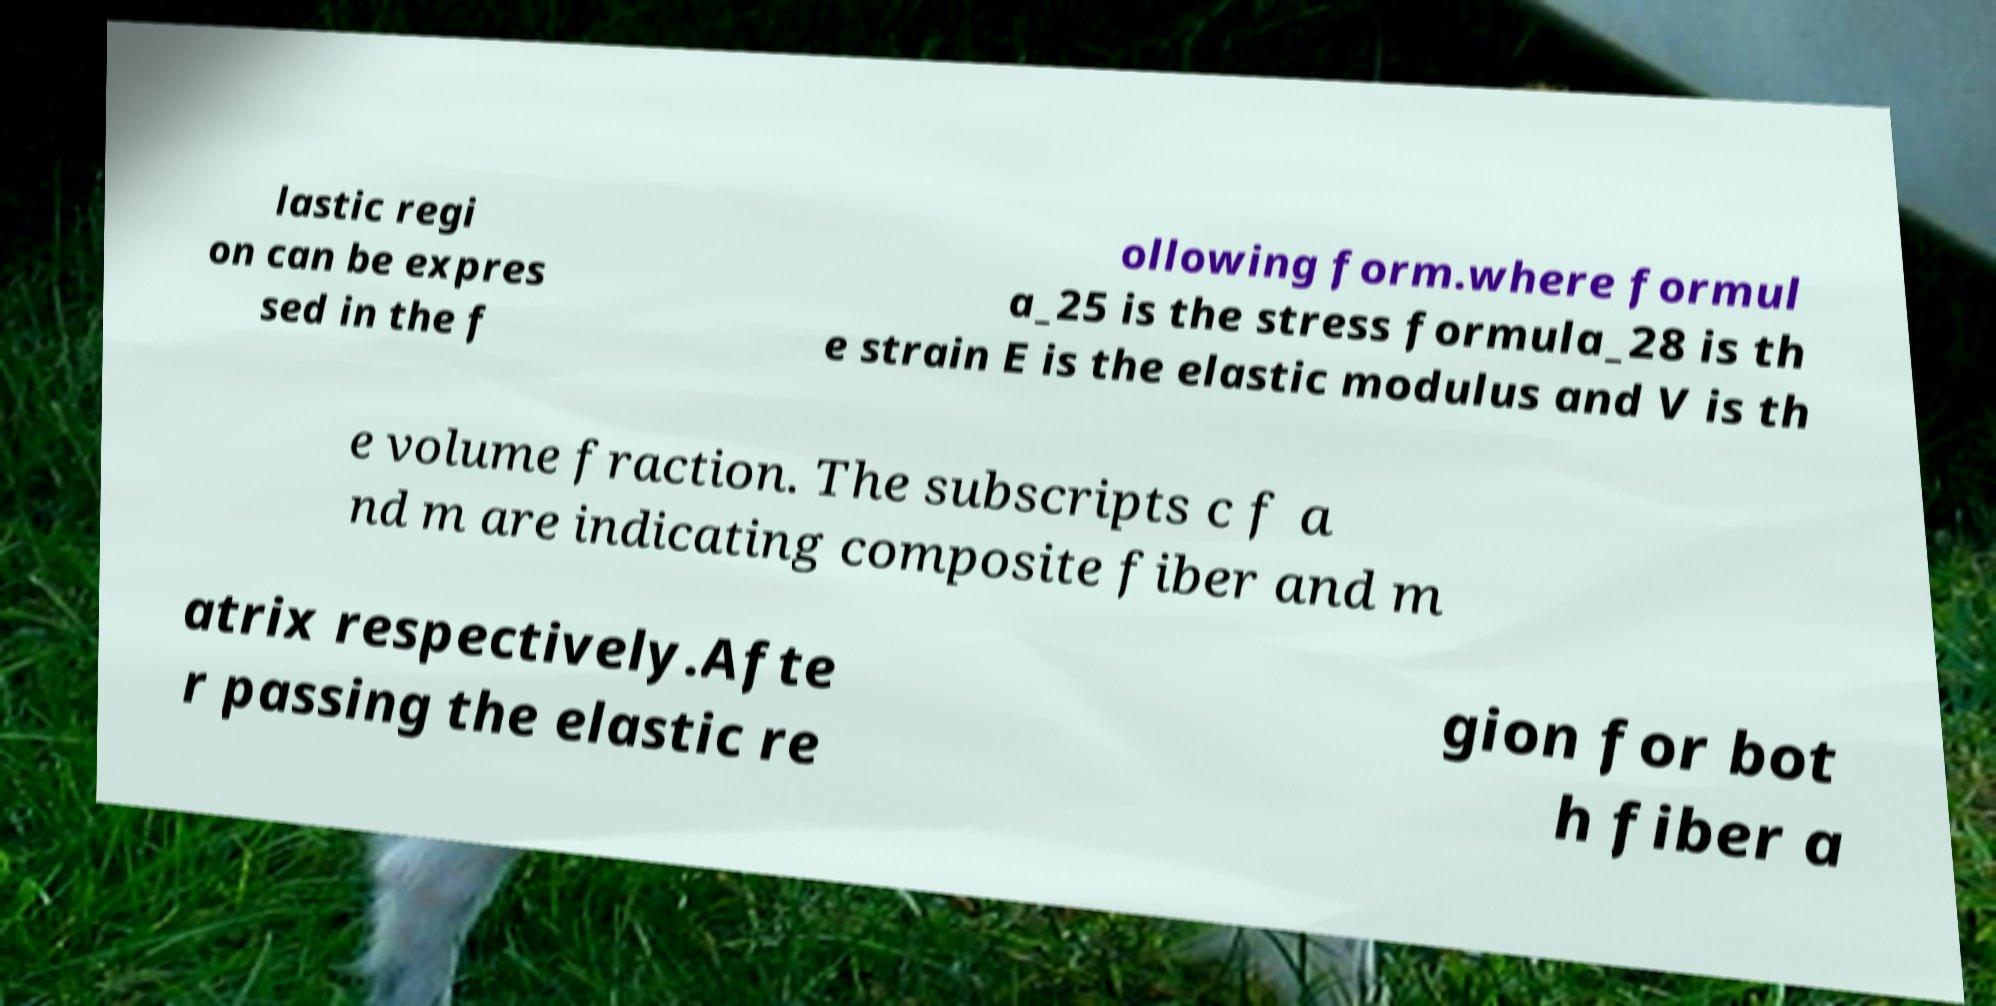There's text embedded in this image that I need extracted. Can you transcribe it verbatim? lastic regi on can be expres sed in the f ollowing form.where formul a_25 is the stress formula_28 is th e strain E is the elastic modulus and V is th e volume fraction. The subscripts c f a nd m are indicating composite fiber and m atrix respectively.Afte r passing the elastic re gion for bot h fiber a 